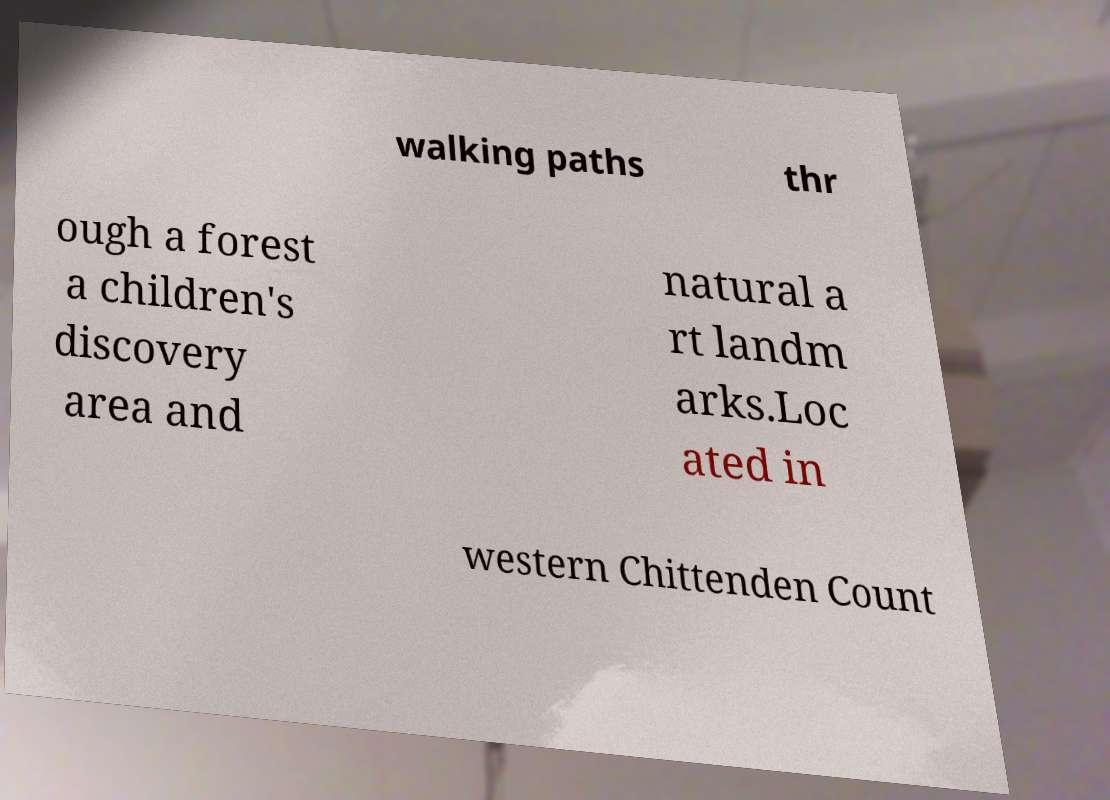Could you extract and type out the text from this image? walking paths thr ough a forest a children's discovery area and natural a rt landm arks.Loc ated in western Chittenden Count 